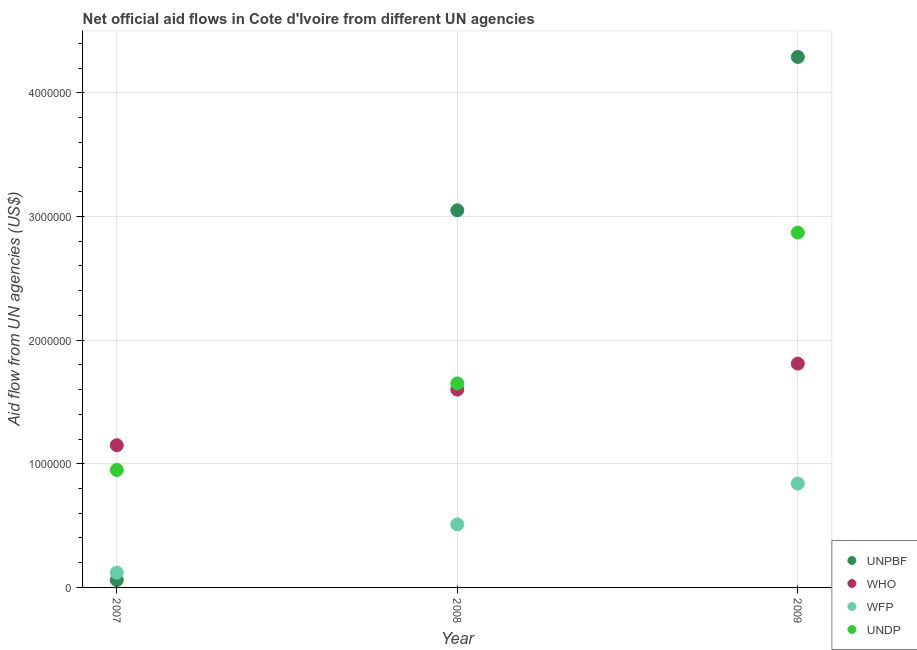Is the number of dotlines equal to the number of legend labels?
Provide a succinct answer. Yes. What is the amount of aid given by wfp in 2009?
Provide a short and direct response. 8.40e+05. Across all years, what is the maximum amount of aid given by undp?
Your answer should be very brief. 2.87e+06. Across all years, what is the minimum amount of aid given by who?
Provide a succinct answer. 1.15e+06. In which year was the amount of aid given by unpbf maximum?
Offer a terse response. 2009. What is the total amount of aid given by unpbf in the graph?
Provide a succinct answer. 7.40e+06. What is the difference between the amount of aid given by undp in 2007 and that in 2008?
Make the answer very short. -7.00e+05. What is the difference between the amount of aid given by who in 2007 and the amount of aid given by undp in 2009?
Give a very brief answer. -1.72e+06. In the year 2008, what is the difference between the amount of aid given by who and amount of aid given by wfp?
Offer a terse response. 1.09e+06. In how many years, is the amount of aid given by undp greater than 200000 US$?
Offer a very short reply. 3. What is the ratio of the amount of aid given by unpbf in 2007 to that in 2009?
Your response must be concise. 0.01. What is the difference between the highest and the second highest amount of aid given by undp?
Keep it short and to the point. 1.22e+06. What is the difference between the highest and the lowest amount of aid given by undp?
Offer a terse response. 1.92e+06. Is it the case that in every year, the sum of the amount of aid given by unpbf and amount of aid given by who is greater than the amount of aid given by wfp?
Offer a terse response. Yes. Is the amount of aid given by wfp strictly greater than the amount of aid given by who over the years?
Provide a succinct answer. No. How many dotlines are there?
Your answer should be very brief. 4. How many years are there in the graph?
Offer a terse response. 3. What is the difference between two consecutive major ticks on the Y-axis?
Offer a terse response. 1.00e+06. Does the graph contain grids?
Provide a succinct answer. Yes. Where does the legend appear in the graph?
Your answer should be compact. Bottom right. How many legend labels are there?
Give a very brief answer. 4. How are the legend labels stacked?
Provide a succinct answer. Vertical. What is the title of the graph?
Provide a short and direct response. Net official aid flows in Cote d'Ivoire from different UN agencies. What is the label or title of the Y-axis?
Your answer should be very brief. Aid flow from UN agencies (US$). What is the Aid flow from UN agencies (US$) in WHO in 2007?
Your answer should be very brief. 1.15e+06. What is the Aid flow from UN agencies (US$) of UNDP in 2007?
Your response must be concise. 9.50e+05. What is the Aid flow from UN agencies (US$) of UNPBF in 2008?
Make the answer very short. 3.05e+06. What is the Aid flow from UN agencies (US$) of WHO in 2008?
Offer a terse response. 1.60e+06. What is the Aid flow from UN agencies (US$) of WFP in 2008?
Provide a short and direct response. 5.10e+05. What is the Aid flow from UN agencies (US$) of UNDP in 2008?
Keep it short and to the point. 1.65e+06. What is the Aid flow from UN agencies (US$) in UNPBF in 2009?
Offer a very short reply. 4.29e+06. What is the Aid flow from UN agencies (US$) of WHO in 2009?
Your response must be concise. 1.81e+06. What is the Aid flow from UN agencies (US$) of WFP in 2009?
Keep it short and to the point. 8.40e+05. What is the Aid flow from UN agencies (US$) of UNDP in 2009?
Your response must be concise. 2.87e+06. Across all years, what is the maximum Aid flow from UN agencies (US$) of UNPBF?
Offer a terse response. 4.29e+06. Across all years, what is the maximum Aid flow from UN agencies (US$) in WHO?
Your answer should be very brief. 1.81e+06. Across all years, what is the maximum Aid flow from UN agencies (US$) of WFP?
Your answer should be very brief. 8.40e+05. Across all years, what is the maximum Aid flow from UN agencies (US$) of UNDP?
Provide a succinct answer. 2.87e+06. Across all years, what is the minimum Aid flow from UN agencies (US$) in WHO?
Make the answer very short. 1.15e+06. Across all years, what is the minimum Aid flow from UN agencies (US$) in UNDP?
Provide a succinct answer. 9.50e+05. What is the total Aid flow from UN agencies (US$) of UNPBF in the graph?
Make the answer very short. 7.40e+06. What is the total Aid flow from UN agencies (US$) of WHO in the graph?
Ensure brevity in your answer.  4.56e+06. What is the total Aid flow from UN agencies (US$) of WFP in the graph?
Offer a terse response. 1.47e+06. What is the total Aid flow from UN agencies (US$) in UNDP in the graph?
Your answer should be compact. 5.47e+06. What is the difference between the Aid flow from UN agencies (US$) in UNPBF in 2007 and that in 2008?
Provide a short and direct response. -2.99e+06. What is the difference between the Aid flow from UN agencies (US$) of WHO in 2007 and that in 2008?
Your answer should be very brief. -4.50e+05. What is the difference between the Aid flow from UN agencies (US$) in WFP in 2007 and that in 2008?
Your response must be concise. -3.90e+05. What is the difference between the Aid flow from UN agencies (US$) of UNDP in 2007 and that in 2008?
Provide a short and direct response. -7.00e+05. What is the difference between the Aid flow from UN agencies (US$) in UNPBF in 2007 and that in 2009?
Offer a very short reply. -4.23e+06. What is the difference between the Aid flow from UN agencies (US$) of WHO in 2007 and that in 2009?
Give a very brief answer. -6.60e+05. What is the difference between the Aid flow from UN agencies (US$) of WFP in 2007 and that in 2009?
Your answer should be very brief. -7.20e+05. What is the difference between the Aid flow from UN agencies (US$) in UNDP in 2007 and that in 2009?
Give a very brief answer. -1.92e+06. What is the difference between the Aid flow from UN agencies (US$) of UNPBF in 2008 and that in 2009?
Your answer should be compact. -1.24e+06. What is the difference between the Aid flow from UN agencies (US$) of WFP in 2008 and that in 2009?
Offer a terse response. -3.30e+05. What is the difference between the Aid flow from UN agencies (US$) in UNDP in 2008 and that in 2009?
Offer a very short reply. -1.22e+06. What is the difference between the Aid flow from UN agencies (US$) in UNPBF in 2007 and the Aid flow from UN agencies (US$) in WHO in 2008?
Offer a very short reply. -1.54e+06. What is the difference between the Aid flow from UN agencies (US$) of UNPBF in 2007 and the Aid flow from UN agencies (US$) of WFP in 2008?
Ensure brevity in your answer.  -4.50e+05. What is the difference between the Aid flow from UN agencies (US$) in UNPBF in 2007 and the Aid flow from UN agencies (US$) in UNDP in 2008?
Provide a succinct answer. -1.59e+06. What is the difference between the Aid flow from UN agencies (US$) of WHO in 2007 and the Aid flow from UN agencies (US$) of WFP in 2008?
Make the answer very short. 6.40e+05. What is the difference between the Aid flow from UN agencies (US$) in WHO in 2007 and the Aid flow from UN agencies (US$) in UNDP in 2008?
Your response must be concise. -5.00e+05. What is the difference between the Aid flow from UN agencies (US$) in WFP in 2007 and the Aid flow from UN agencies (US$) in UNDP in 2008?
Give a very brief answer. -1.53e+06. What is the difference between the Aid flow from UN agencies (US$) in UNPBF in 2007 and the Aid flow from UN agencies (US$) in WHO in 2009?
Keep it short and to the point. -1.75e+06. What is the difference between the Aid flow from UN agencies (US$) of UNPBF in 2007 and the Aid flow from UN agencies (US$) of WFP in 2009?
Make the answer very short. -7.80e+05. What is the difference between the Aid flow from UN agencies (US$) of UNPBF in 2007 and the Aid flow from UN agencies (US$) of UNDP in 2009?
Your answer should be very brief. -2.81e+06. What is the difference between the Aid flow from UN agencies (US$) in WHO in 2007 and the Aid flow from UN agencies (US$) in WFP in 2009?
Provide a short and direct response. 3.10e+05. What is the difference between the Aid flow from UN agencies (US$) in WHO in 2007 and the Aid flow from UN agencies (US$) in UNDP in 2009?
Keep it short and to the point. -1.72e+06. What is the difference between the Aid flow from UN agencies (US$) in WFP in 2007 and the Aid flow from UN agencies (US$) in UNDP in 2009?
Your answer should be compact. -2.75e+06. What is the difference between the Aid flow from UN agencies (US$) of UNPBF in 2008 and the Aid flow from UN agencies (US$) of WHO in 2009?
Give a very brief answer. 1.24e+06. What is the difference between the Aid flow from UN agencies (US$) of UNPBF in 2008 and the Aid flow from UN agencies (US$) of WFP in 2009?
Make the answer very short. 2.21e+06. What is the difference between the Aid flow from UN agencies (US$) of UNPBF in 2008 and the Aid flow from UN agencies (US$) of UNDP in 2009?
Your answer should be very brief. 1.80e+05. What is the difference between the Aid flow from UN agencies (US$) of WHO in 2008 and the Aid flow from UN agencies (US$) of WFP in 2009?
Ensure brevity in your answer.  7.60e+05. What is the difference between the Aid flow from UN agencies (US$) of WHO in 2008 and the Aid flow from UN agencies (US$) of UNDP in 2009?
Ensure brevity in your answer.  -1.27e+06. What is the difference between the Aid flow from UN agencies (US$) in WFP in 2008 and the Aid flow from UN agencies (US$) in UNDP in 2009?
Your answer should be compact. -2.36e+06. What is the average Aid flow from UN agencies (US$) of UNPBF per year?
Provide a short and direct response. 2.47e+06. What is the average Aid flow from UN agencies (US$) of WHO per year?
Give a very brief answer. 1.52e+06. What is the average Aid flow from UN agencies (US$) of UNDP per year?
Make the answer very short. 1.82e+06. In the year 2007, what is the difference between the Aid flow from UN agencies (US$) in UNPBF and Aid flow from UN agencies (US$) in WHO?
Your answer should be compact. -1.09e+06. In the year 2007, what is the difference between the Aid flow from UN agencies (US$) in UNPBF and Aid flow from UN agencies (US$) in WFP?
Your response must be concise. -6.00e+04. In the year 2007, what is the difference between the Aid flow from UN agencies (US$) of UNPBF and Aid flow from UN agencies (US$) of UNDP?
Your response must be concise. -8.90e+05. In the year 2007, what is the difference between the Aid flow from UN agencies (US$) of WHO and Aid flow from UN agencies (US$) of WFP?
Provide a short and direct response. 1.03e+06. In the year 2007, what is the difference between the Aid flow from UN agencies (US$) in WFP and Aid flow from UN agencies (US$) in UNDP?
Ensure brevity in your answer.  -8.30e+05. In the year 2008, what is the difference between the Aid flow from UN agencies (US$) in UNPBF and Aid flow from UN agencies (US$) in WHO?
Your response must be concise. 1.45e+06. In the year 2008, what is the difference between the Aid flow from UN agencies (US$) in UNPBF and Aid flow from UN agencies (US$) in WFP?
Your answer should be compact. 2.54e+06. In the year 2008, what is the difference between the Aid flow from UN agencies (US$) of UNPBF and Aid flow from UN agencies (US$) of UNDP?
Give a very brief answer. 1.40e+06. In the year 2008, what is the difference between the Aid flow from UN agencies (US$) in WHO and Aid flow from UN agencies (US$) in WFP?
Your response must be concise. 1.09e+06. In the year 2008, what is the difference between the Aid flow from UN agencies (US$) in WHO and Aid flow from UN agencies (US$) in UNDP?
Your answer should be very brief. -5.00e+04. In the year 2008, what is the difference between the Aid flow from UN agencies (US$) in WFP and Aid flow from UN agencies (US$) in UNDP?
Your answer should be very brief. -1.14e+06. In the year 2009, what is the difference between the Aid flow from UN agencies (US$) of UNPBF and Aid flow from UN agencies (US$) of WHO?
Keep it short and to the point. 2.48e+06. In the year 2009, what is the difference between the Aid flow from UN agencies (US$) in UNPBF and Aid flow from UN agencies (US$) in WFP?
Provide a short and direct response. 3.45e+06. In the year 2009, what is the difference between the Aid flow from UN agencies (US$) in UNPBF and Aid flow from UN agencies (US$) in UNDP?
Offer a very short reply. 1.42e+06. In the year 2009, what is the difference between the Aid flow from UN agencies (US$) in WHO and Aid flow from UN agencies (US$) in WFP?
Offer a terse response. 9.70e+05. In the year 2009, what is the difference between the Aid flow from UN agencies (US$) in WHO and Aid flow from UN agencies (US$) in UNDP?
Offer a very short reply. -1.06e+06. In the year 2009, what is the difference between the Aid flow from UN agencies (US$) in WFP and Aid flow from UN agencies (US$) in UNDP?
Offer a terse response. -2.03e+06. What is the ratio of the Aid flow from UN agencies (US$) in UNPBF in 2007 to that in 2008?
Give a very brief answer. 0.02. What is the ratio of the Aid flow from UN agencies (US$) in WHO in 2007 to that in 2008?
Ensure brevity in your answer.  0.72. What is the ratio of the Aid flow from UN agencies (US$) of WFP in 2007 to that in 2008?
Provide a short and direct response. 0.24. What is the ratio of the Aid flow from UN agencies (US$) in UNDP in 2007 to that in 2008?
Keep it short and to the point. 0.58. What is the ratio of the Aid flow from UN agencies (US$) of UNPBF in 2007 to that in 2009?
Make the answer very short. 0.01. What is the ratio of the Aid flow from UN agencies (US$) of WHO in 2007 to that in 2009?
Make the answer very short. 0.64. What is the ratio of the Aid flow from UN agencies (US$) in WFP in 2007 to that in 2009?
Offer a terse response. 0.14. What is the ratio of the Aid flow from UN agencies (US$) in UNDP in 2007 to that in 2009?
Provide a succinct answer. 0.33. What is the ratio of the Aid flow from UN agencies (US$) in UNPBF in 2008 to that in 2009?
Provide a succinct answer. 0.71. What is the ratio of the Aid flow from UN agencies (US$) of WHO in 2008 to that in 2009?
Your answer should be compact. 0.88. What is the ratio of the Aid flow from UN agencies (US$) in WFP in 2008 to that in 2009?
Offer a terse response. 0.61. What is the ratio of the Aid flow from UN agencies (US$) of UNDP in 2008 to that in 2009?
Provide a short and direct response. 0.57. What is the difference between the highest and the second highest Aid flow from UN agencies (US$) of UNPBF?
Give a very brief answer. 1.24e+06. What is the difference between the highest and the second highest Aid flow from UN agencies (US$) in WHO?
Provide a succinct answer. 2.10e+05. What is the difference between the highest and the second highest Aid flow from UN agencies (US$) of UNDP?
Give a very brief answer. 1.22e+06. What is the difference between the highest and the lowest Aid flow from UN agencies (US$) in UNPBF?
Your response must be concise. 4.23e+06. What is the difference between the highest and the lowest Aid flow from UN agencies (US$) in WFP?
Make the answer very short. 7.20e+05. What is the difference between the highest and the lowest Aid flow from UN agencies (US$) of UNDP?
Keep it short and to the point. 1.92e+06. 